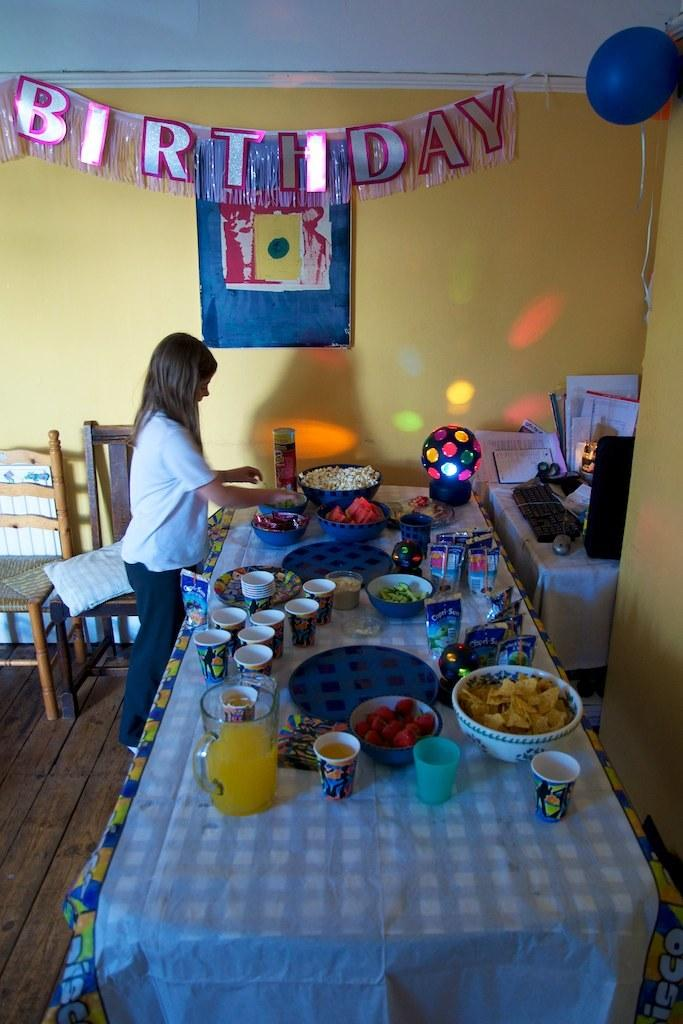What color is the wall that is visible in the image? There is a yellow color wall in the image. What type of furniture can be seen in the image? There are chairs in the image. Who is present in the image? There is a man standing in the image. What is on the table in the image? There are glasses, bowls, mugs, and plates on the table. What type of roof can be seen in the image? There is no roof visible in the image; it only shows a wall, chairs, a table, and various objects on the table. What kind of bait is being used by the man in the image? There is no indication of fishing or bait in the image; it only shows a man standing near a table with various objects on it. 